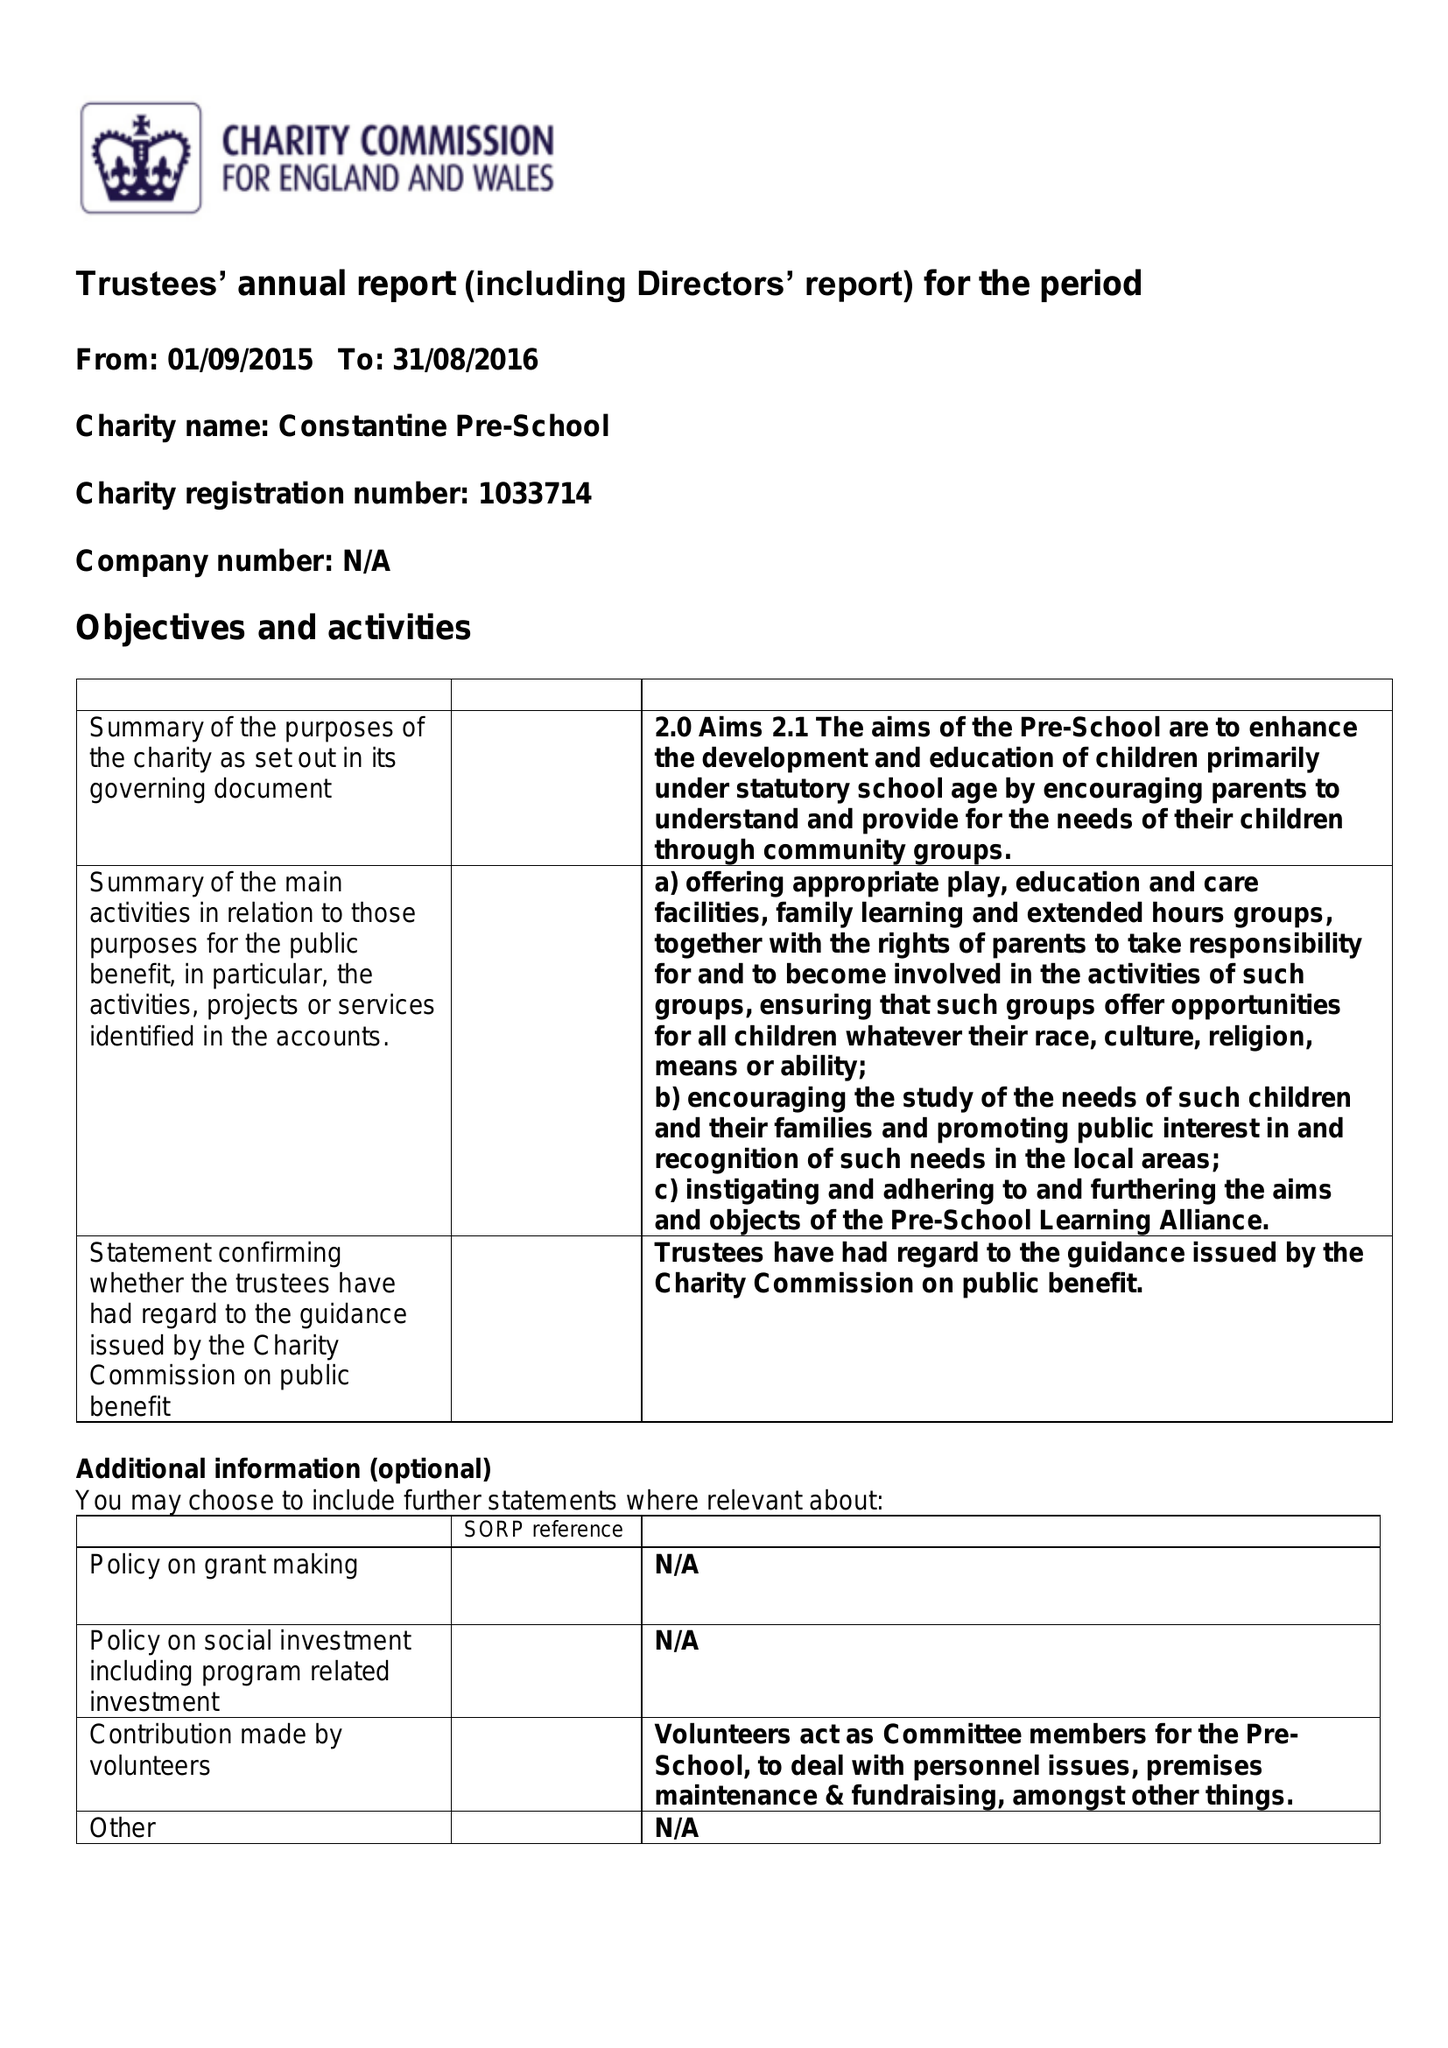What is the value for the charity_number?
Answer the question using a single word or phrase. 1033714 